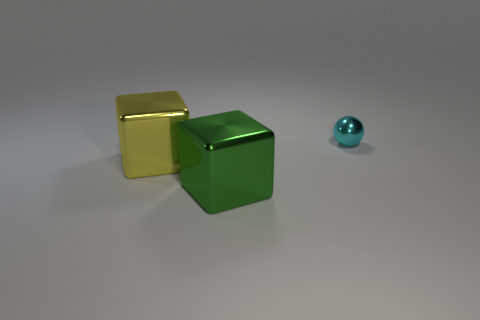Add 3 big green metal things. How many objects exist? 6 Subtract all cubes. How many objects are left? 1 Subtract all yellow metallic objects. Subtract all tiny objects. How many objects are left? 1 Add 3 cyan metal balls. How many cyan metal balls are left? 4 Add 1 cyan metallic things. How many cyan metallic things exist? 2 Subtract 0 blue spheres. How many objects are left? 3 